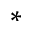Convert formula to latex. <formula><loc_0><loc_0><loc_500><loc_500>^ { * }</formula> 